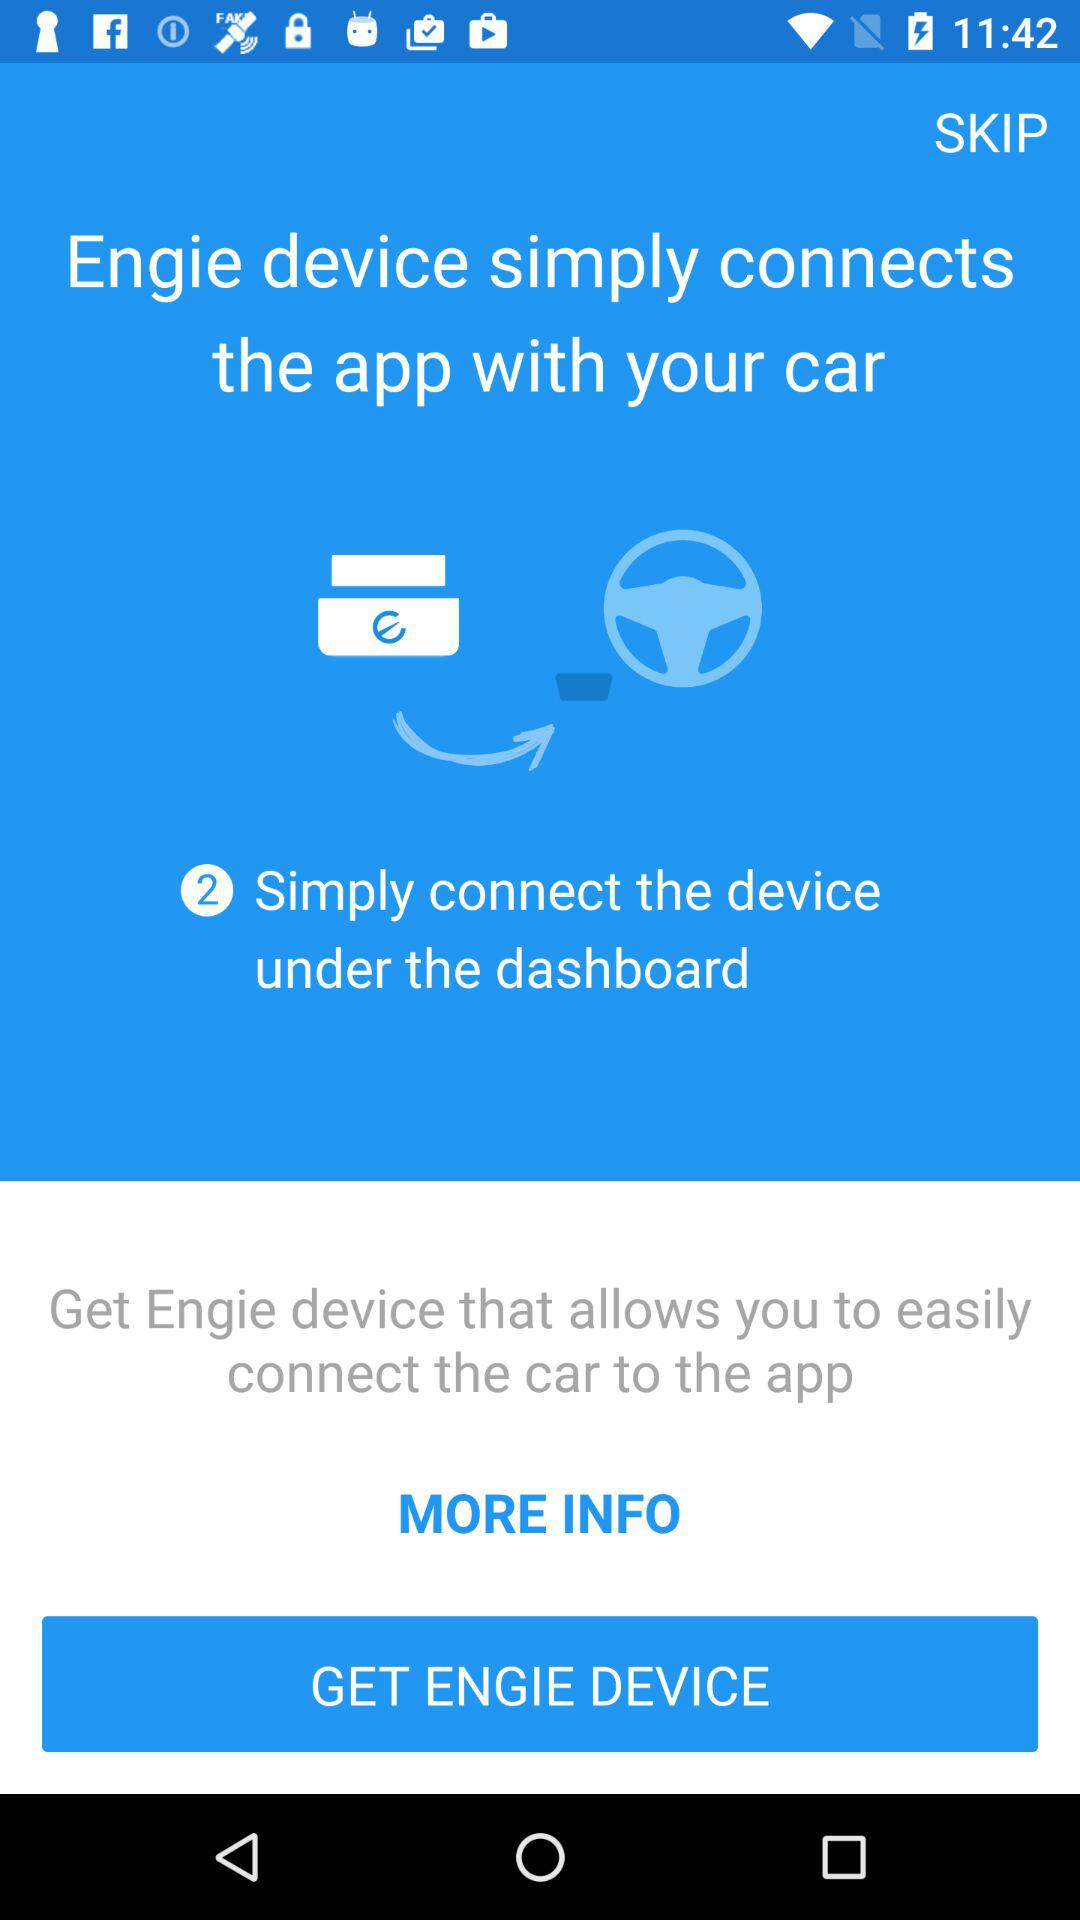How much does the "Englie" device cost?
When the provided information is insufficient, respond with <no answer>. <no answer> 